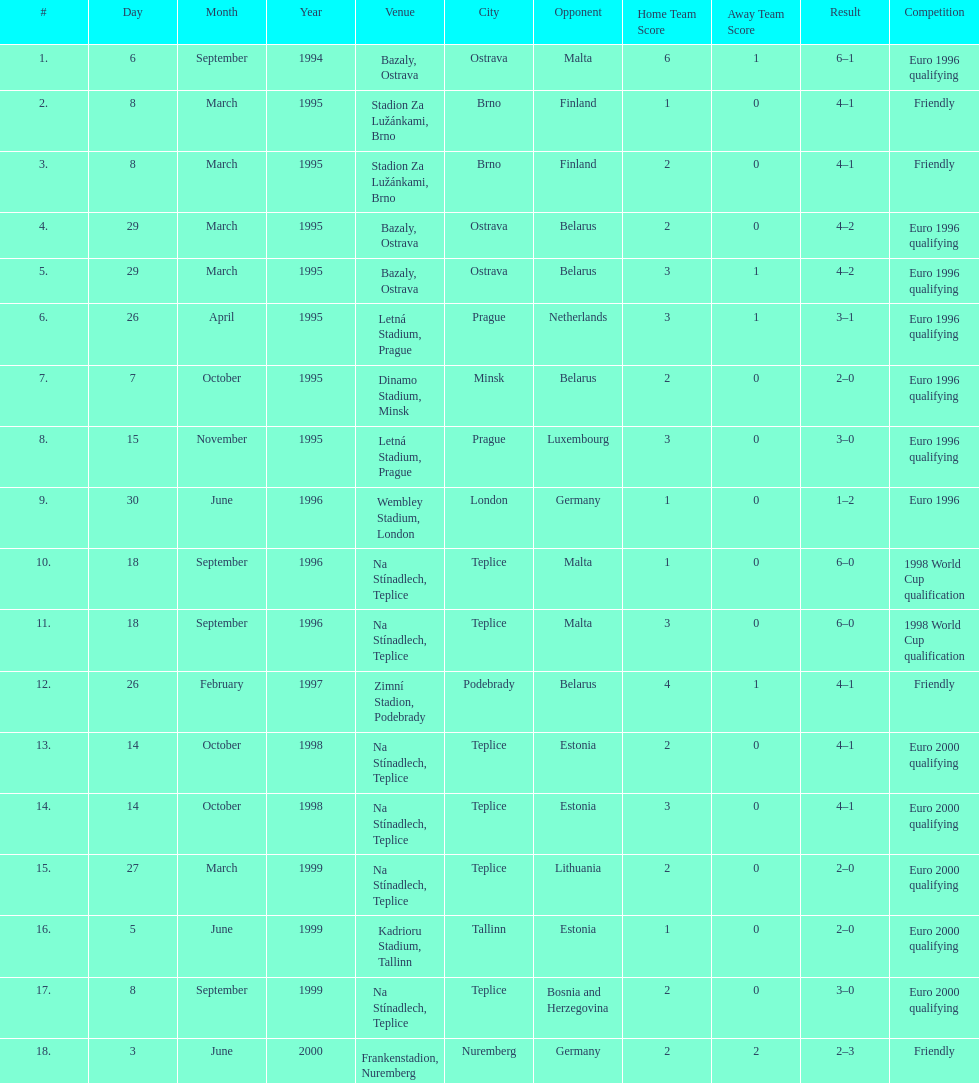What opponent is listed last on the table? Germany. 